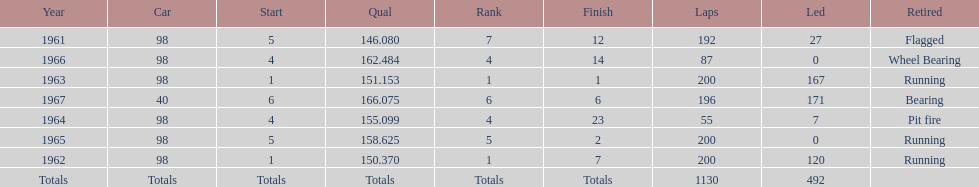How many times did he finish in the top three? 2. 